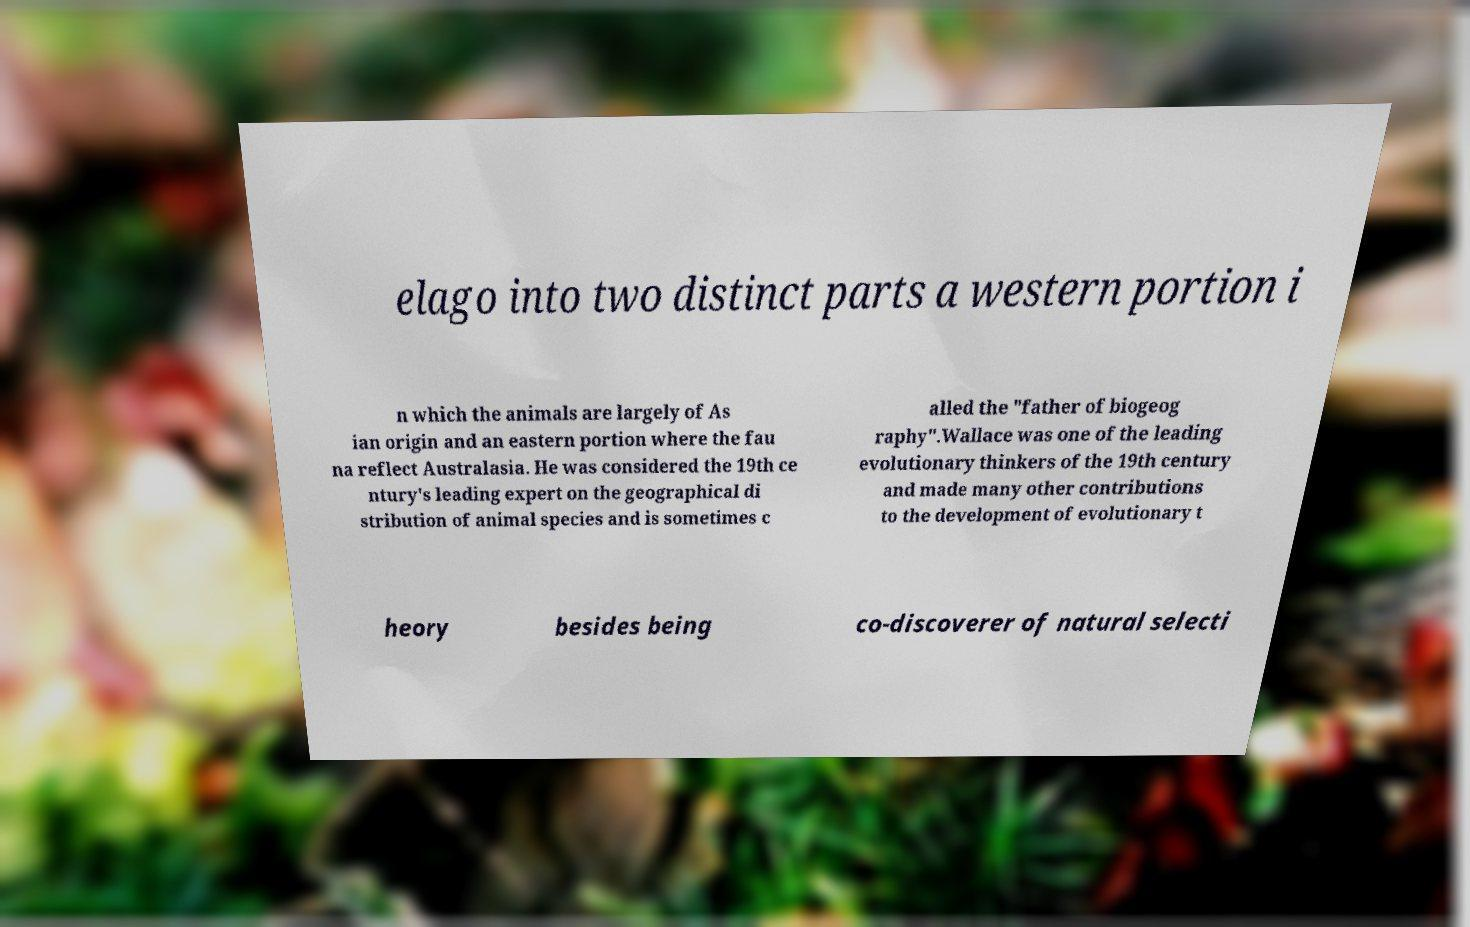Could you assist in decoding the text presented in this image and type it out clearly? elago into two distinct parts a western portion i n which the animals are largely of As ian origin and an eastern portion where the fau na reflect Australasia. He was considered the 19th ce ntury's leading expert on the geographical di stribution of animal species and is sometimes c alled the "father of biogeog raphy".Wallace was one of the leading evolutionary thinkers of the 19th century and made many other contributions to the development of evolutionary t heory besides being co-discoverer of natural selecti 